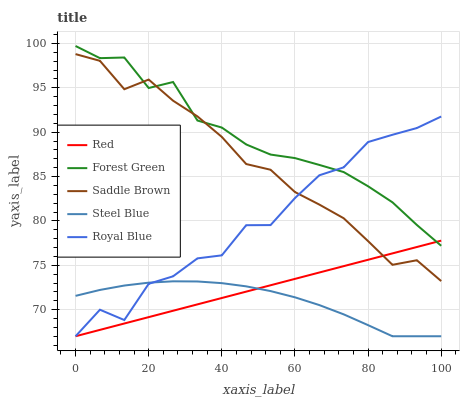Does Steel Blue have the minimum area under the curve?
Answer yes or no. Yes. Does Forest Green have the maximum area under the curve?
Answer yes or no. Yes. Does Saddle Brown have the minimum area under the curve?
Answer yes or no. No. Does Saddle Brown have the maximum area under the curve?
Answer yes or no. No. Is Red the smoothest?
Answer yes or no. Yes. Is Royal Blue the roughest?
Answer yes or no. Yes. Is Forest Green the smoothest?
Answer yes or no. No. Is Forest Green the roughest?
Answer yes or no. No. Does Royal Blue have the lowest value?
Answer yes or no. Yes. Does Saddle Brown have the lowest value?
Answer yes or no. No. Does Forest Green have the highest value?
Answer yes or no. Yes. Does Saddle Brown have the highest value?
Answer yes or no. No. Is Steel Blue less than Saddle Brown?
Answer yes or no. Yes. Is Forest Green greater than Steel Blue?
Answer yes or no. Yes. Does Red intersect Saddle Brown?
Answer yes or no. Yes. Is Red less than Saddle Brown?
Answer yes or no. No. Is Red greater than Saddle Brown?
Answer yes or no. No. Does Steel Blue intersect Saddle Brown?
Answer yes or no. No. 